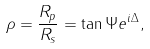<formula> <loc_0><loc_0><loc_500><loc_500>\rho = \frac { R _ { p } } { R _ { s } } = \tan \Psi e ^ { i \Delta } ,</formula> 